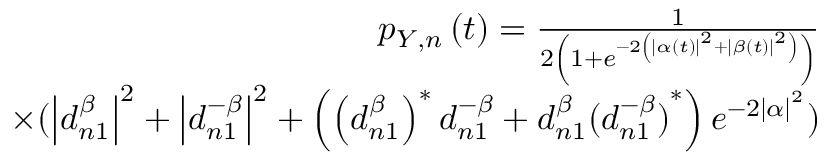Convert formula to latex. <formula><loc_0><loc_0><loc_500><loc_500>\begin{array} { r } { p _ { Y , n } \left ( t \right ) = \frac { 1 } { 2 \left ( 1 + e ^ { - 2 \left ( \left | \alpha \left ( t \right ) \right | ^ { 2 } + \left | \beta \left ( t \right ) \right | ^ { 2 } \right ) } \right ) } } \\ { \times ( \left | d _ { n 1 } ^ { \beta } \right | ^ { 2 } + \left | d _ { n 1 } ^ { - \beta } \right | ^ { 2 } + \left ( \left ( d _ { n 1 } ^ { \beta } \right ) ^ { \ast } d _ { n 1 } ^ { - \beta } + d _ { n 1 } ^ { \beta } { ( d _ { n 1 } ^ { - \beta } ) } ^ { \ast } \right ) e ^ { - 2 \left | \alpha \right | ^ { 2 } } ) } \end{array}</formula> 